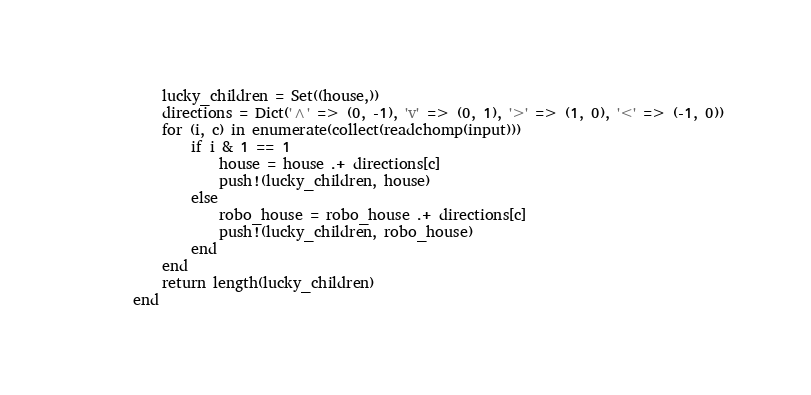Convert code to text. <code><loc_0><loc_0><loc_500><loc_500><_Julia_>    lucky_children = Set((house,))
    directions = Dict('^' => (0, -1), 'v' => (0, 1), '>' => (1, 0), '<' => (-1, 0))
    for (i, c) in enumerate(collect(readchomp(input)))
        if i & 1 == 1
            house = house .+ directions[c]
            push!(lucky_children, house)
        else
            robo_house = robo_house .+ directions[c]
            push!(lucky_children, robo_house)
        end
    end
    return length(lucky_children)
end
</code> 